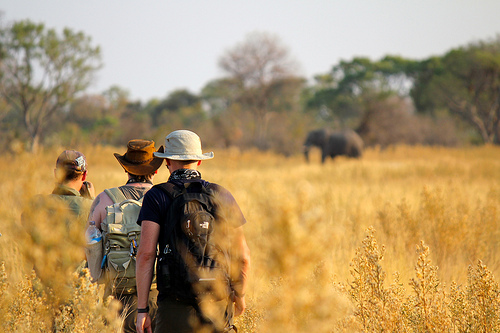Do you see an elephant in the scene that is small? No, the elephant in the scene is not small. 